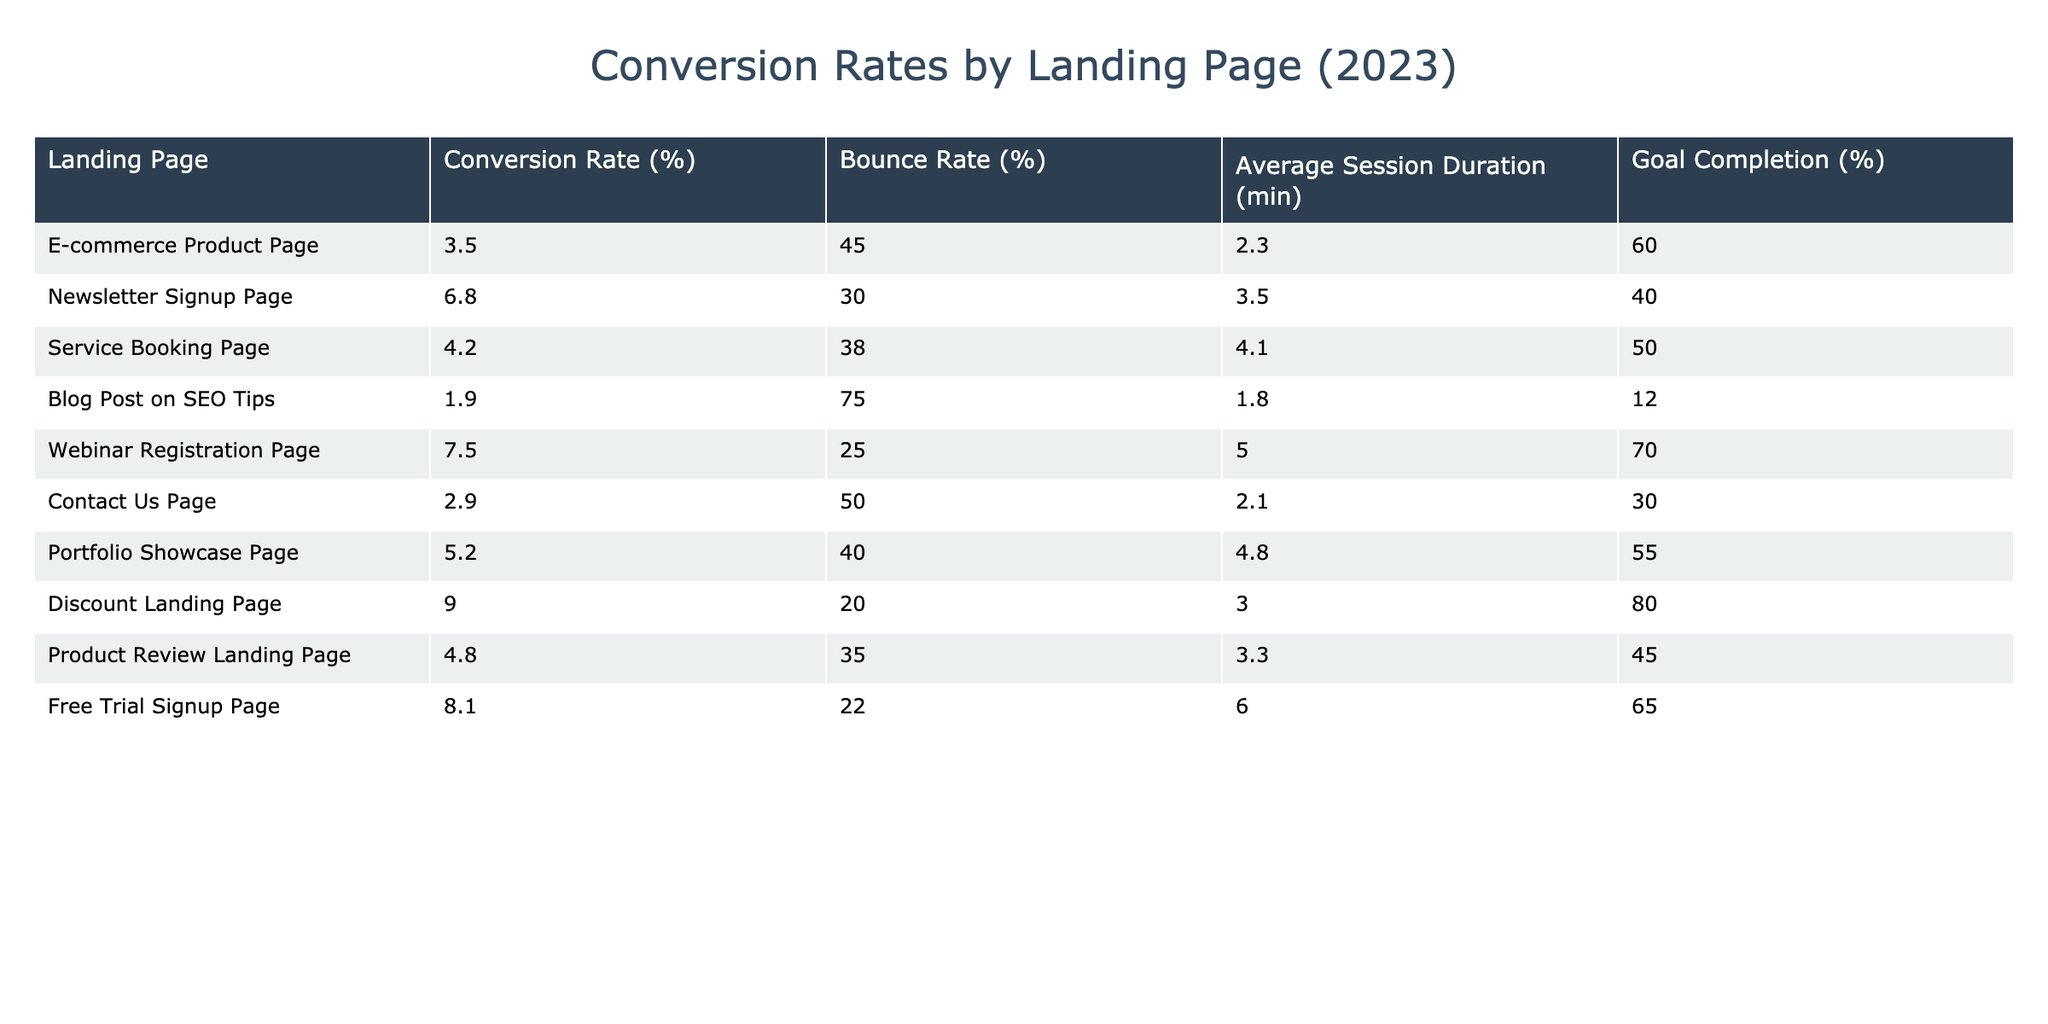What is the landing page with the highest conversion rate? By inspecting the 'Conversion Rate (%)' column in the table, we can see that the 'Discount Landing Page' has the highest value at 9.0%.
Answer: Discount Landing Page Which landing page has the lowest bounce rate? Looking at the 'Bounce Rate (%)' column, 'Discount Landing Page' has the lowest bounce rate at 20%.
Answer: Discount Landing Page What is the average conversion rate for all landing pages listed? To find the average conversion rate, we sum the conversion rates: (3.5 + 6.8 + 4.2 + 1.9 + 7.5 + 2.9 + 5.2 + 9.0 + 4.8 + 8.1) = 53.0. There are 10 landing pages, so the average is 53.0 / 10 = 5.3%.
Answer: 5.3 Is the 'Webinar Registration Page' performing better than the 'Newsletter Signup Page' in terms of goal completion? We can find the goal completion percentages of both pages: 'Webinar Registration Page' is at 70% and 'Newsletter Signup Page' is at 40%. Since 70% is greater than 40%, the 'Webinar Registration Page' is performing better.
Answer: Yes What is the difference in average session duration between the highest and lowest conversion rates? The 'Discount Landing Page' has the highest conversion rate with an average session duration of 3.0 minutes, while the 'Blog Post on SEO Tips' with the lowest conversion rate has 1.8 minutes. The difference is 3.0 - 1.8 = 1.2 minutes.
Answer: 1.2 minutes Which landing page has a goal completion rate that is more than 60%? From the table, we can identify pages with goal completion rates above 60%. 'Webinar Registration Page' (70%), 'Discount Landing Page' (80%), and 'Free Trial Signup Page' (65%) all exceed 60%.
Answer: Webinar Registration Page, Discount Landing Page, Free Trial Signup Page How many landing pages have a conversion rate above 5%? We check the conversion rates: 'Newsletter Signup Page' (6.8%), 'Webinar Registration Page' (7.5%), 'Discount Landing Page' (9.0%), and 'Free Trial Signup Page' (8.1%). There are 4 pages with conversion rates above 5%.
Answer: 4 Is there a correlation between the bounce rate and conversion rate? By examining the bounce rate and conversion rate, we see that landing pages with lower bounce rates often have higher conversion rates (e.g. 'Discount Landing Page' with 20% bounce and 9% conversion). This suggests an inverse relationship, indicating a negative correlation.
Answer: Yes 